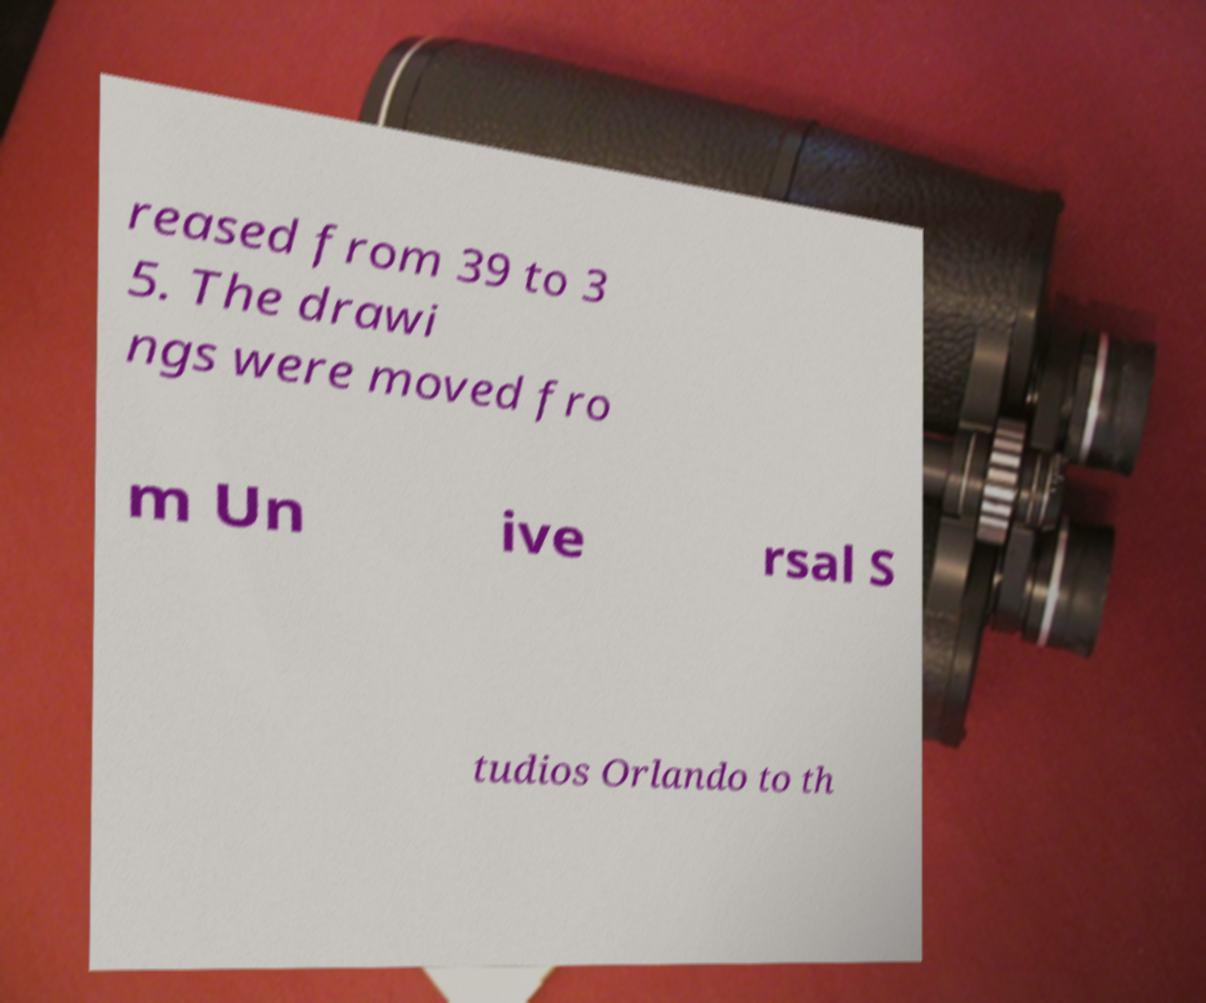Could you assist in decoding the text presented in this image and type it out clearly? reased from 39 to 3 5. The drawi ngs were moved fro m Un ive rsal S tudios Orlando to th 